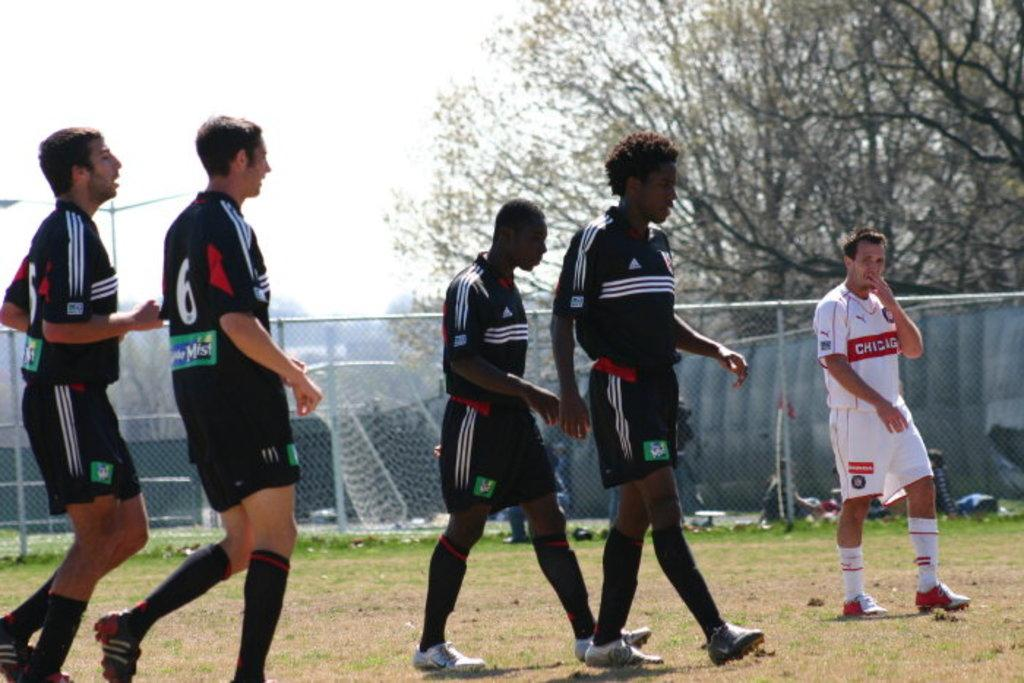<image>
Relay a brief, clear account of the picture shown. Player number 6 in black walks on a soccer field during a game. 